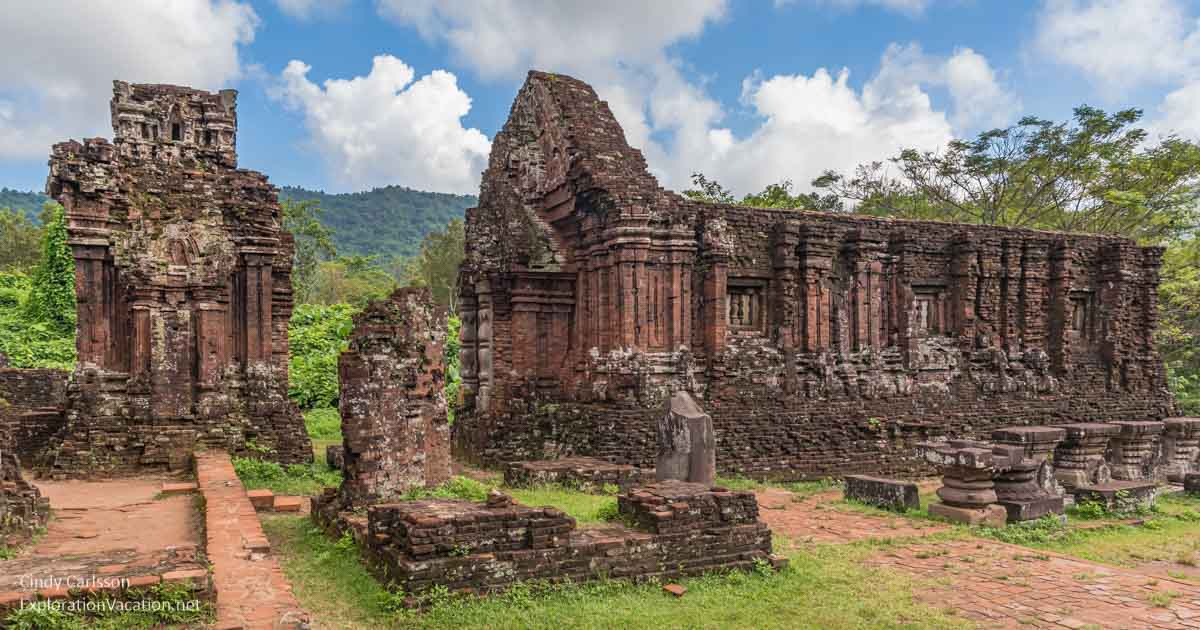Can you describe the historical significance of the My Son temple complex? The My Son temple complex holds immense historical significance as it was a religious hub for the Champa Kingdom between the 4th and 13th centuries. These temples were dedicated to Hindu deities, most notably Shiva, and served as a site for religious ceremonies and the burial of kings and national heroes. The architecture, characterized by red brick towers and intricate carvings, reflects the influence of Indian culture and serves as a testament to the Champa civilization's sophistication and spiritual devotion. What kind of ceremonies were carried out here? The My Son temple complex was primarily used for Hindu religious ceremonies, including rituals to honor the Hindu deities, performances of traditional music and dance, and the crowning and burial of kings. These ceremonies were integral to the socio-political life of the Champa kingdom, often involving elaborate offerings and rites to appease the gods and ancestors. The site also witnessed the performance of yajnas (sacrificial rituals), which were believed to sustain the cosmological order and ensure the kingdom's prosperity. Imagine if the temple complex could speak. What stories would it tell us? If the temple complex could speak, it would weave tales of grandeur and devotion, recounting the chants of priests, the echoes of sacred ceremonies, and the vibrant festivals that filled its courtyards. It would tell of the kings and warriors who sought blessings before battles, the artists and craftsmen who adorned its walls with intricate carvings, and the evolution of a civilization that revered it as a divine sanctuary. The temple would narrate stories of resilience against nature's elements and human conflicts that sought to conquer its sacred grounds, reflecting its enduring spirit throughout centuries. 